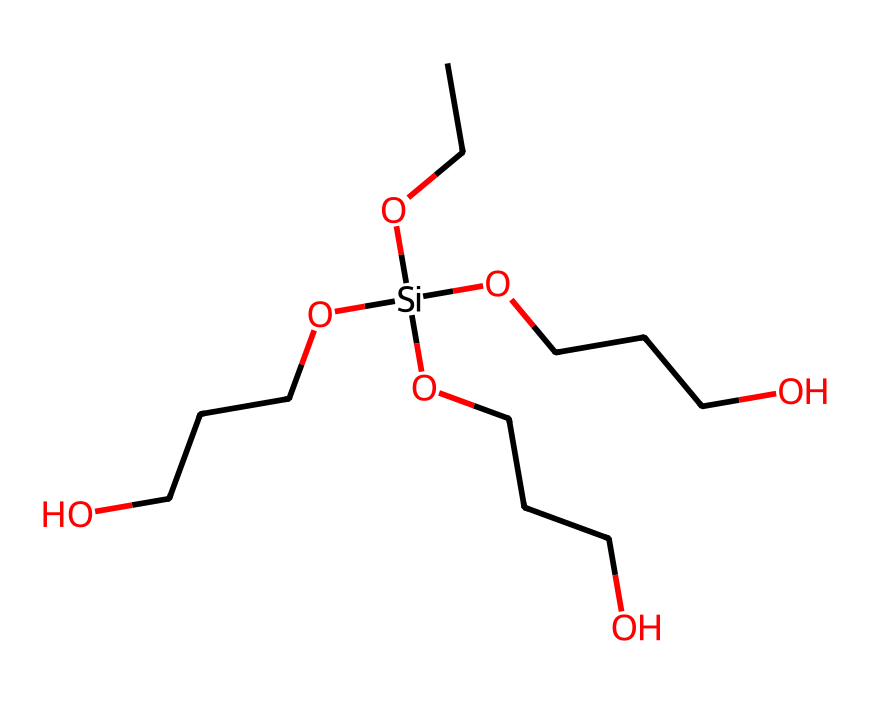How many silicon atoms are present in the molecule? The SMILES representation contains one occurrence of 'Si', indicating that there is one silicon atom in the structure.
Answer: one What functional groups are present in this silane? The structure shows multiple -OCCCO groups, which indicate ether functional groups due to the presence of oxygen bonded to carbon chains.
Answer: ether How many ethoxy groups are there in the chemical structure? The structure has four occurrences of 'OCCCO', indicating that there are four ethoxy groups attached to the silicon atom.
Answer: four What is the primary use of silane coupling agents in medical devices? Silane coupling agents are primarily used to enhance adhesion between organic and inorganic materials, improving the performance of coatings in medical equipment.
Answer: adhesion What is the general role of silane coupling agents in respiratory equipment? Silane coupling agents improve the biocompatibility and surface properties of equipment, ensuring better interaction with respiratory tissues.
Answer: biocompatibility What type of reaction mechanism might be expected during the application of silanes in coatings? Silanes typically undergo hydrolysis followed by condensation, forming a siloxane network, which enhances the durability of the coating.
Answer: hydrolysis and condensation 